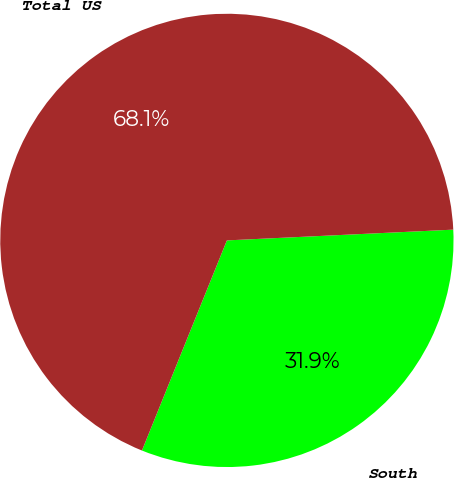<chart> <loc_0><loc_0><loc_500><loc_500><pie_chart><fcel>South<fcel>Total US<nl><fcel>31.87%<fcel>68.13%<nl></chart> 